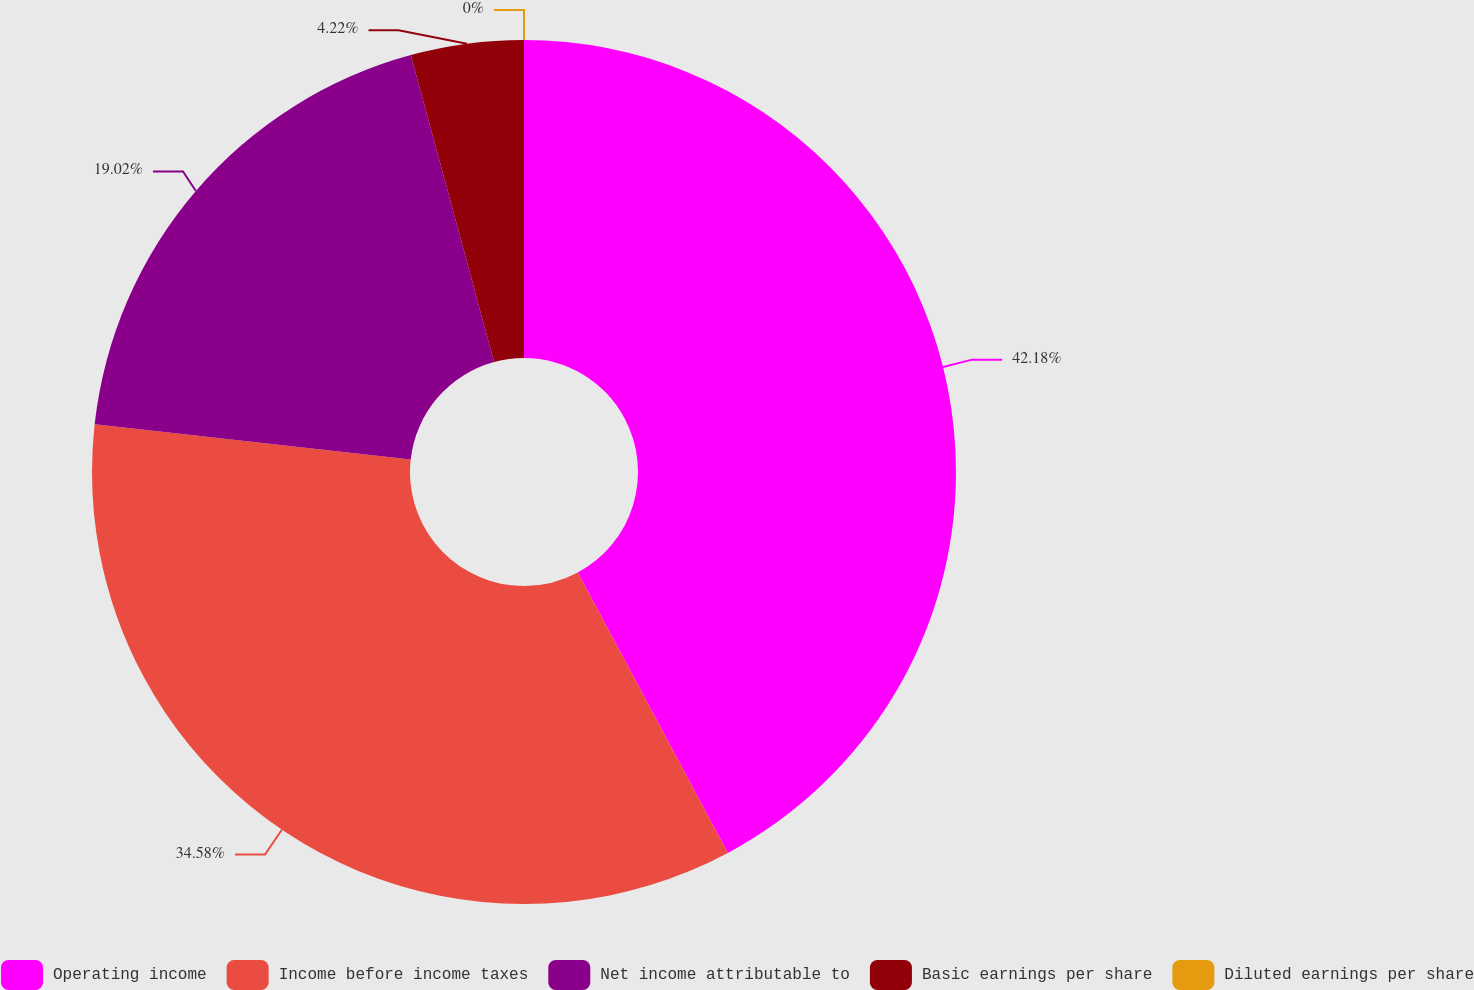Convert chart to OTSL. <chart><loc_0><loc_0><loc_500><loc_500><pie_chart><fcel>Operating income<fcel>Income before income taxes<fcel>Net income attributable to<fcel>Basic earnings per share<fcel>Diluted earnings per share<nl><fcel>42.18%<fcel>34.58%<fcel>19.02%<fcel>4.22%<fcel>0.0%<nl></chart> 